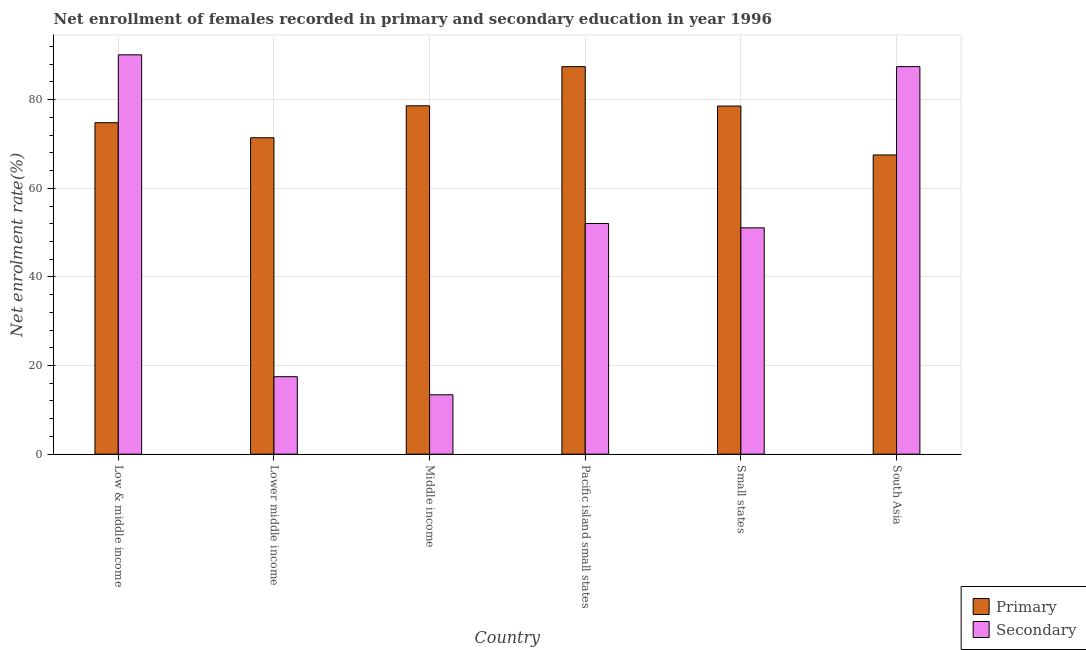How many different coloured bars are there?
Your answer should be compact. 2. Are the number of bars per tick equal to the number of legend labels?
Give a very brief answer. Yes. Are the number of bars on each tick of the X-axis equal?
Offer a terse response. Yes. How many bars are there on the 5th tick from the left?
Offer a very short reply. 2. How many bars are there on the 1st tick from the right?
Ensure brevity in your answer.  2. What is the label of the 4th group of bars from the left?
Keep it short and to the point. Pacific island small states. What is the enrollment rate in primary education in Low & middle income?
Offer a very short reply. 74.8. Across all countries, what is the maximum enrollment rate in secondary education?
Your response must be concise. 90.12. Across all countries, what is the minimum enrollment rate in primary education?
Your response must be concise. 67.52. In which country was the enrollment rate in primary education maximum?
Your answer should be compact. Pacific island small states. What is the total enrollment rate in secondary education in the graph?
Your answer should be compact. 311.6. What is the difference between the enrollment rate in primary education in Pacific island small states and that in South Asia?
Provide a short and direct response. 19.92. What is the difference between the enrollment rate in secondary education in Lower middle income and the enrollment rate in primary education in South Asia?
Provide a succinct answer. -50.04. What is the average enrollment rate in primary education per country?
Your answer should be compact. 76.39. What is the difference between the enrollment rate in primary education and enrollment rate in secondary education in South Asia?
Your response must be concise. -19.93. What is the ratio of the enrollment rate in primary education in Middle income to that in Pacific island small states?
Offer a terse response. 0.9. Is the difference between the enrollment rate in primary education in Middle income and Pacific island small states greater than the difference between the enrollment rate in secondary education in Middle income and Pacific island small states?
Your response must be concise. Yes. What is the difference between the highest and the second highest enrollment rate in primary education?
Ensure brevity in your answer.  8.83. What is the difference between the highest and the lowest enrollment rate in primary education?
Ensure brevity in your answer.  19.92. What does the 1st bar from the left in Lower middle income represents?
Provide a succinct answer. Primary. What does the 2nd bar from the right in Lower middle income represents?
Your response must be concise. Primary. How many countries are there in the graph?
Ensure brevity in your answer.  6. What is the difference between two consecutive major ticks on the Y-axis?
Keep it short and to the point. 20. Does the graph contain any zero values?
Ensure brevity in your answer.  No. Does the graph contain grids?
Ensure brevity in your answer.  Yes. Where does the legend appear in the graph?
Provide a succinct answer. Bottom right. What is the title of the graph?
Offer a terse response. Net enrollment of females recorded in primary and secondary education in year 1996. What is the label or title of the X-axis?
Provide a succinct answer. Country. What is the label or title of the Y-axis?
Offer a terse response. Net enrolment rate(%). What is the Net enrolment rate(%) of Primary in Low & middle income?
Your response must be concise. 74.8. What is the Net enrolment rate(%) in Secondary in Low & middle income?
Give a very brief answer. 90.12. What is the Net enrolment rate(%) in Primary in Lower middle income?
Make the answer very short. 71.41. What is the Net enrolment rate(%) in Secondary in Lower middle income?
Give a very brief answer. 17.48. What is the Net enrolment rate(%) in Primary in Middle income?
Your answer should be compact. 78.62. What is the Net enrolment rate(%) in Secondary in Middle income?
Ensure brevity in your answer.  13.4. What is the Net enrolment rate(%) in Primary in Pacific island small states?
Your answer should be very brief. 87.45. What is the Net enrolment rate(%) in Secondary in Pacific island small states?
Keep it short and to the point. 52.06. What is the Net enrolment rate(%) in Primary in Small states?
Provide a succinct answer. 78.56. What is the Net enrolment rate(%) of Secondary in Small states?
Provide a succinct answer. 51.08. What is the Net enrolment rate(%) in Primary in South Asia?
Ensure brevity in your answer.  67.52. What is the Net enrolment rate(%) of Secondary in South Asia?
Provide a short and direct response. 87.46. Across all countries, what is the maximum Net enrolment rate(%) of Primary?
Your answer should be very brief. 87.45. Across all countries, what is the maximum Net enrolment rate(%) in Secondary?
Make the answer very short. 90.12. Across all countries, what is the minimum Net enrolment rate(%) of Primary?
Offer a very short reply. 67.52. Across all countries, what is the minimum Net enrolment rate(%) of Secondary?
Offer a very short reply. 13.4. What is the total Net enrolment rate(%) of Primary in the graph?
Provide a short and direct response. 458.37. What is the total Net enrolment rate(%) of Secondary in the graph?
Offer a terse response. 311.6. What is the difference between the Net enrolment rate(%) in Primary in Low & middle income and that in Lower middle income?
Your response must be concise. 3.4. What is the difference between the Net enrolment rate(%) in Secondary in Low & middle income and that in Lower middle income?
Provide a succinct answer. 72.64. What is the difference between the Net enrolment rate(%) in Primary in Low & middle income and that in Middle income?
Give a very brief answer. -3.81. What is the difference between the Net enrolment rate(%) in Secondary in Low & middle income and that in Middle income?
Offer a terse response. 76.71. What is the difference between the Net enrolment rate(%) in Primary in Low & middle income and that in Pacific island small states?
Your response must be concise. -12.64. What is the difference between the Net enrolment rate(%) of Secondary in Low & middle income and that in Pacific island small states?
Your response must be concise. 38.06. What is the difference between the Net enrolment rate(%) of Primary in Low & middle income and that in Small states?
Offer a terse response. -3.76. What is the difference between the Net enrolment rate(%) in Secondary in Low & middle income and that in Small states?
Make the answer very short. 39.04. What is the difference between the Net enrolment rate(%) in Primary in Low & middle income and that in South Asia?
Keep it short and to the point. 7.28. What is the difference between the Net enrolment rate(%) in Secondary in Low & middle income and that in South Asia?
Give a very brief answer. 2.66. What is the difference between the Net enrolment rate(%) in Primary in Lower middle income and that in Middle income?
Your answer should be compact. -7.21. What is the difference between the Net enrolment rate(%) of Secondary in Lower middle income and that in Middle income?
Give a very brief answer. 4.08. What is the difference between the Net enrolment rate(%) of Primary in Lower middle income and that in Pacific island small states?
Your answer should be very brief. -16.04. What is the difference between the Net enrolment rate(%) in Secondary in Lower middle income and that in Pacific island small states?
Make the answer very short. -34.58. What is the difference between the Net enrolment rate(%) of Primary in Lower middle income and that in Small states?
Provide a succinct answer. -7.16. What is the difference between the Net enrolment rate(%) in Secondary in Lower middle income and that in Small states?
Your answer should be compact. -33.6. What is the difference between the Net enrolment rate(%) in Primary in Lower middle income and that in South Asia?
Provide a short and direct response. 3.88. What is the difference between the Net enrolment rate(%) of Secondary in Lower middle income and that in South Asia?
Give a very brief answer. -69.98. What is the difference between the Net enrolment rate(%) of Primary in Middle income and that in Pacific island small states?
Make the answer very short. -8.83. What is the difference between the Net enrolment rate(%) in Secondary in Middle income and that in Pacific island small states?
Provide a succinct answer. -38.66. What is the difference between the Net enrolment rate(%) in Primary in Middle income and that in Small states?
Provide a short and direct response. 0.05. What is the difference between the Net enrolment rate(%) of Secondary in Middle income and that in Small states?
Give a very brief answer. -37.67. What is the difference between the Net enrolment rate(%) of Primary in Middle income and that in South Asia?
Provide a short and direct response. 11.09. What is the difference between the Net enrolment rate(%) in Secondary in Middle income and that in South Asia?
Your answer should be compact. -74.05. What is the difference between the Net enrolment rate(%) in Primary in Pacific island small states and that in Small states?
Provide a succinct answer. 8.89. What is the difference between the Net enrolment rate(%) of Secondary in Pacific island small states and that in Small states?
Make the answer very short. 0.98. What is the difference between the Net enrolment rate(%) of Primary in Pacific island small states and that in South Asia?
Offer a very short reply. 19.92. What is the difference between the Net enrolment rate(%) of Secondary in Pacific island small states and that in South Asia?
Provide a short and direct response. -35.4. What is the difference between the Net enrolment rate(%) of Primary in Small states and that in South Asia?
Offer a terse response. 11.04. What is the difference between the Net enrolment rate(%) of Secondary in Small states and that in South Asia?
Ensure brevity in your answer.  -36.38. What is the difference between the Net enrolment rate(%) of Primary in Low & middle income and the Net enrolment rate(%) of Secondary in Lower middle income?
Offer a very short reply. 57.32. What is the difference between the Net enrolment rate(%) in Primary in Low & middle income and the Net enrolment rate(%) in Secondary in Middle income?
Your answer should be compact. 61.4. What is the difference between the Net enrolment rate(%) of Primary in Low & middle income and the Net enrolment rate(%) of Secondary in Pacific island small states?
Offer a terse response. 22.74. What is the difference between the Net enrolment rate(%) of Primary in Low & middle income and the Net enrolment rate(%) of Secondary in Small states?
Offer a very short reply. 23.73. What is the difference between the Net enrolment rate(%) of Primary in Low & middle income and the Net enrolment rate(%) of Secondary in South Asia?
Provide a succinct answer. -12.65. What is the difference between the Net enrolment rate(%) in Primary in Lower middle income and the Net enrolment rate(%) in Secondary in Middle income?
Your response must be concise. 58. What is the difference between the Net enrolment rate(%) in Primary in Lower middle income and the Net enrolment rate(%) in Secondary in Pacific island small states?
Offer a terse response. 19.35. What is the difference between the Net enrolment rate(%) of Primary in Lower middle income and the Net enrolment rate(%) of Secondary in Small states?
Your response must be concise. 20.33. What is the difference between the Net enrolment rate(%) in Primary in Lower middle income and the Net enrolment rate(%) in Secondary in South Asia?
Provide a succinct answer. -16.05. What is the difference between the Net enrolment rate(%) of Primary in Middle income and the Net enrolment rate(%) of Secondary in Pacific island small states?
Your response must be concise. 26.56. What is the difference between the Net enrolment rate(%) of Primary in Middle income and the Net enrolment rate(%) of Secondary in Small states?
Provide a succinct answer. 27.54. What is the difference between the Net enrolment rate(%) in Primary in Middle income and the Net enrolment rate(%) in Secondary in South Asia?
Give a very brief answer. -8.84. What is the difference between the Net enrolment rate(%) in Primary in Pacific island small states and the Net enrolment rate(%) in Secondary in Small states?
Give a very brief answer. 36.37. What is the difference between the Net enrolment rate(%) of Primary in Pacific island small states and the Net enrolment rate(%) of Secondary in South Asia?
Provide a succinct answer. -0.01. What is the difference between the Net enrolment rate(%) in Primary in Small states and the Net enrolment rate(%) in Secondary in South Asia?
Give a very brief answer. -8.89. What is the average Net enrolment rate(%) of Primary per country?
Your response must be concise. 76.39. What is the average Net enrolment rate(%) in Secondary per country?
Your answer should be compact. 51.93. What is the difference between the Net enrolment rate(%) in Primary and Net enrolment rate(%) in Secondary in Low & middle income?
Your response must be concise. -15.31. What is the difference between the Net enrolment rate(%) in Primary and Net enrolment rate(%) in Secondary in Lower middle income?
Make the answer very short. 53.93. What is the difference between the Net enrolment rate(%) in Primary and Net enrolment rate(%) in Secondary in Middle income?
Keep it short and to the point. 65.21. What is the difference between the Net enrolment rate(%) in Primary and Net enrolment rate(%) in Secondary in Pacific island small states?
Your answer should be compact. 35.39. What is the difference between the Net enrolment rate(%) of Primary and Net enrolment rate(%) of Secondary in Small states?
Offer a terse response. 27.49. What is the difference between the Net enrolment rate(%) in Primary and Net enrolment rate(%) in Secondary in South Asia?
Your answer should be compact. -19.93. What is the ratio of the Net enrolment rate(%) in Primary in Low & middle income to that in Lower middle income?
Offer a terse response. 1.05. What is the ratio of the Net enrolment rate(%) of Secondary in Low & middle income to that in Lower middle income?
Give a very brief answer. 5.16. What is the ratio of the Net enrolment rate(%) of Primary in Low & middle income to that in Middle income?
Keep it short and to the point. 0.95. What is the ratio of the Net enrolment rate(%) in Secondary in Low & middle income to that in Middle income?
Provide a short and direct response. 6.72. What is the ratio of the Net enrolment rate(%) of Primary in Low & middle income to that in Pacific island small states?
Ensure brevity in your answer.  0.86. What is the ratio of the Net enrolment rate(%) in Secondary in Low & middle income to that in Pacific island small states?
Provide a short and direct response. 1.73. What is the ratio of the Net enrolment rate(%) in Primary in Low & middle income to that in Small states?
Provide a short and direct response. 0.95. What is the ratio of the Net enrolment rate(%) in Secondary in Low & middle income to that in Small states?
Give a very brief answer. 1.76. What is the ratio of the Net enrolment rate(%) of Primary in Low & middle income to that in South Asia?
Your answer should be compact. 1.11. What is the ratio of the Net enrolment rate(%) of Secondary in Low & middle income to that in South Asia?
Keep it short and to the point. 1.03. What is the ratio of the Net enrolment rate(%) of Primary in Lower middle income to that in Middle income?
Give a very brief answer. 0.91. What is the ratio of the Net enrolment rate(%) in Secondary in Lower middle income to that in Middle income?
Offer a very short reply. 1.3. What is the ratio of the Net enrolment rate(%) in Primary in Lower middle income to that in Pacific island small states?
Keep it short and to the point. 0.82. What is the ratio of the Net enrolment rate(%) in Secondary in Lower middle income to that in Pacific island small states?
Make the answer very short. 0.34. What is the ratio of the Net enrolment rate(%) of Primary in Lower middle income to that in Small states?
Offer a very short reply. 0.91. What is the ratio of the Net enrolment rate(%) in Secondary in Lower middle income to that in Small states?
Ensure brevity in your answer.  0.34. What is the ratio of the Net enrolment rate(%) in Primary in Lower middle income to that in South Asia?
Provide a succinct answer. 1.06. What is the ratio of the Net enrolment rate(%) of Secondary in Lower middle income to that in South Asia?
Provide a succinct answer. 0.2. What is the ratio of the Net enrolment rate(%) of Primary in Middle income to that in Pacific island small states?
Keep it short and to the point. 0.9. What is the ratio of the Net enrolment rate(%) of Secondary in Middle income to that in Pacific island small states?
Your response must be concise. 0.26. What is the ratio of the Net enrolment rate(%) of Secondary in Middle income to that in Small states?
Your response must be concise. 0.26. What is the ratio of the Net enrolment rate(%) in Primary in Middle income to that in South Asia?
Offer a very short reply. 1.16. What is the ratio of the Net enrolment rate(%) in Secondary in Middle income to that in South Asia?
Provide a short and direct response. 0.15. What is the ratio of the Net enrolment rate(%) in Primary in Pacific island small states to that in Small states?
Your answer should be compact. 1.11. What is the ratio of the Net enrolment rate(%) in Secondary in Pacific island small states to that in Small states?
Keep it short and to the point. 1.02. What is the ratio of the Net enrolment rate(%) of Primary in Pacific island small states to that in South Asia?
Keep it short and to the point. 1.3. What is the ratio of the Net enrolment rate(%) of Secondary in Pacific island small states to that in South Asia?
Offer a terse response. 0.6. What is the ratio of the Net enrolment rate(%) of Primary in Small states to that in South Asia?
Keep it short and to the point. 1.16. What is the ratio of the Net enrolment rate(%) in Secondary in Small states to that in South Asia?
Your answer should be very brief. 0.58. What is the difference between the highest and the second highest Net enrolment rate(%) in Primary?
Your response must be concise. 8.83. What is the difference between the highest and the second highest Net enrolment rate(%) in Secondary?
Provide a succinct answer. 2.66. What is the difference between the highest and the lowest Net enrolment rate(%) in Primary?
Make the answer very short. 19.92. What is the difference between the highest and the lowest Net enrolment rate(%) in Secondary?
Offer a very short reply. 76.71. 